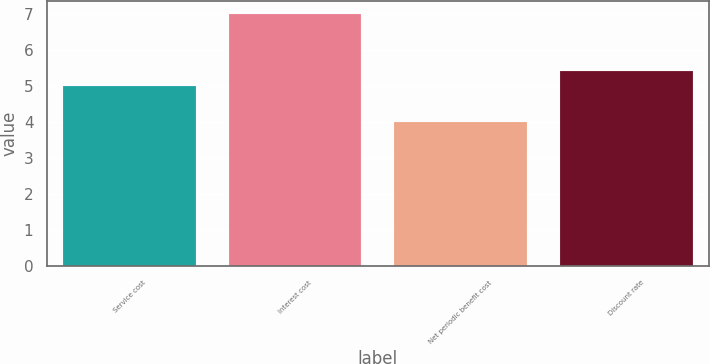Convert chart to OTSL. <chart><loc_0><loc_0><loc_500><loc_500><bar_chart><fcel>Service cost<fcel>Interest cost<fcel>Net periodic benefit cost<fcel>Discount rate<nl><fcel>5<fcel>7<fcel>4<fcel>5.4<nl></chart> 